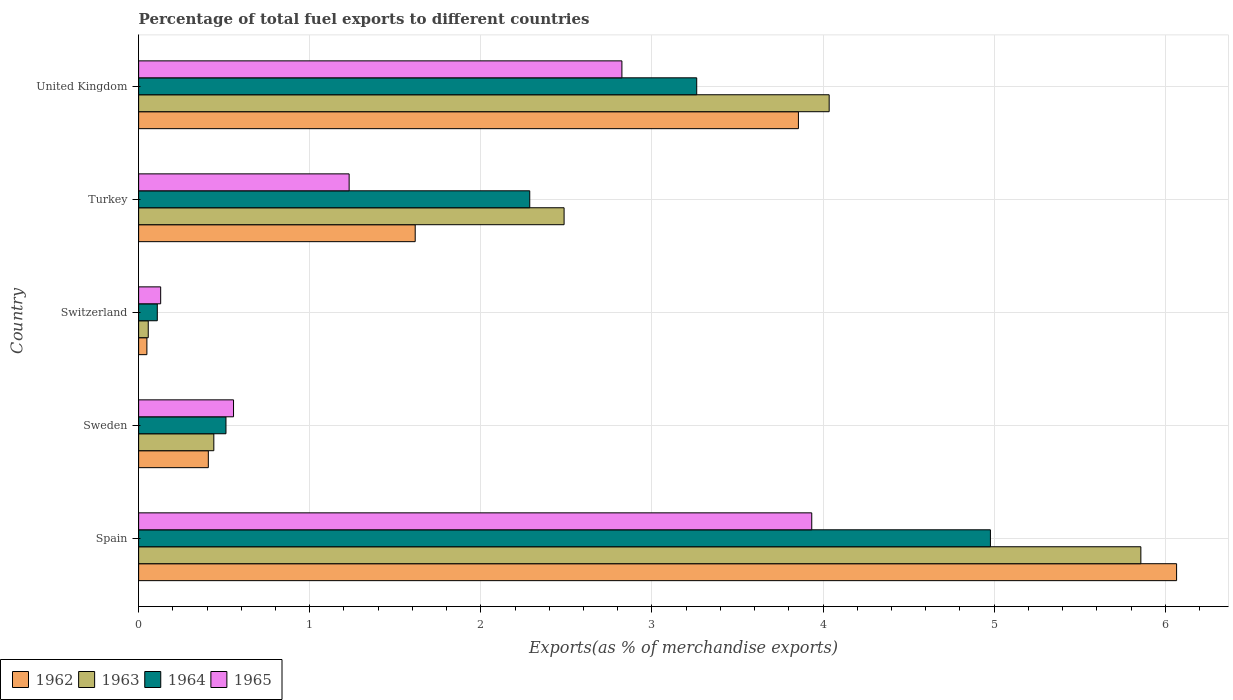Are the number of bars per tick equal to the number of legend labels?
Provide a succinct answer. Yes. How many bars are there on the 4th tick from the top?
Make the answer very short. 4. What is the label of the 4th group of bars from the top?
Your response must be concise. Sweden. In how many cases, is the number of bars for a given country not equal to the number of legend labels?
Provide a succinct answer. 0. What is the percentage of exports to different countries in 1963 in United Kingdom?
Make the answer very short. 4.04. Across all countries, what is the maximum percentage of exports to different countries in 1962?
Your answer should be very brief. 6.07. Across all countries, what is the minimum percentage of exports to different countries in 1963?
Your response must be concise. 0.06. In which country was the percentage of exports to different countries in 1962 maximum?
Make the answer very short. Spain. In which country was the percentage of exports to different countries in 1963 minimum?
Make the answer very short. Switzerland. What is the total percentage of exports to different countries in 1963 in the graph?
Give a very brief answer. 12.88. What is the difference between the percentage of exports to different countries in 1963 in Spain and that in Switzerland?
Give a very brief answer. 5.8. What is the difference between the percentage of exports to different countries in 1963 in Turkey and the percentage of exports to different countries in 1962 in United Kingdom?
Give a very brief answer. -1.37. What is the average percentage of exports to different countries in 1963 per country?
Your answer should be very brief. 2.58. What is the difference between the percentage of exports to different countries in 1965 and percentage of exports to different countries in 1962 in Switzerland?
Offer a terse response. 0.08. What is the ratio of the percentage of exports to different countries in 1965 in Spain to that in Sweden?
Give a very brief answer. 7.09. Is the percentage of exports to different countries in 1963 in Switzerland less than that in United Kingdom?
Ensure brevity in your answer.  Yes. Is the difference between the percentage of exports to different countries in 1965 in Switzerland and United Kingdom greater than the difference between the percentage of exports to different countries in 1962 in Switzerland and United Kingdom?
Your answer should be very brief. Yes. What is the difference between the highest and the second highest percentage of exports to different countries in 1965?
Give a very brief answer. 1.11. What is the difference between the highest and the lowest percentage of exports to different countries in 1962?
Provide a short and direct response. 6.02. What does the 2nd bar from the top in Spain represents?
Offer a terse response. 1964. Does the graph contain any zero values?
Ensure brevity in your answer.  No. Does the graph contain grids?
Your response must be concise. Yes. How many legend labels are there?
Give a very brief answer. 4. How are the legend labels stacked?
Your answer should be very brief. Horizontal. What is the title of the graph?
Keep it short and to the point. Percentage of total fuel exports to different countries. What is the label or title of the X-axis?
Ensure brevity in your answer.  Exports(as % of merchandise exports). What is the Exports(as % of merchandise exports) in 1962 in Spain?
Provide a short and direct response. 6.07. What is the Exports(as % of merchandise exports) of 1963 in Spain?
Make the answer very short. 5.86. What is the Exports(as % of merchandise exports) in 1964 in Spain?
Give a very brief answer. 4.98. What is the Exports(as % of merchandise exports) of 1965 in Spain?
Your response must be concise. 3.93. What is the Exports(as % of merchandise exports) in 1962 in Sweden?
Your answer should be compact. 0.41. What is the Exports(as % of merchandise exports) in 1963 in Sweden?
Offer a very short reply. 0.44. What is the Exports(as % of merchandise exports) of 1964 in Sweden?
Keep it short and to the point. 0.51. What is the Exports(as % of merchandise exports) in 1965 in Sweden?
Offer a very short reply. 0.55. What is the Exports(as % of merchandise exports) in 1962 in Switzerland?
Offer a very short reply. 0.05. What is the Exports(as % of merchandise exports) of 1963 in Switzerland?
Offer a terse response. 0.06. What is the Exports(as % of merchandise exports) in 1964 in Switzerland?
Ensure brevity in your answer.  0.11. What is the Exports(as % of merchandise exports) of 1965 in Switzerland?
Your answer should be compact. 0.13. What is the Exports(as % of merchandise exports) of 1962 in Turkey?
Offer a very short reply. 1.62. What is the Exports(as % of merchandise exports) of 1963 in Turkey?
Keep it short and to the point. 2.49. What is the Exports(as % of merchandise exports) in 1964 in Turkey?
Make the answer very short. 2.29. What is the Exports(as % of merchandise exports) in 1965 in Turkey?
Offer a very short reply. 1.23. What is the Exports(as % of merchandise exports) in 1962 in United Kingdom?
Your answer should be compact. 3.86. What is the Exports(as % of merchandise exports) of 1963 in United Kingdom?
Make the answer very short. 4.04. What is the Exports(as % of merchandise exports) of 1964 in United Kingdom?
Your response must be concise. 3.26. What is the Exports(as % of merchandise exports) of 1965 in United Kingdom?
Provide a succinct answer. 2.82. Across all countries, what is the maximum Exports(as % of merchandise exports) in 1962?
Give a very brief answer. 6.07. Across all countries, what is the maximum Exports(as % of merchandise exports) in 1963?
Keep it short and to the point. 5.86. Across all countries, what is the maximum Exports(as % of merchandise exports) of 1964?
Make the answer very short. 4.98. Across all countries, what is the maximum Exports(as % of merchandise exports) in 1965?
Offer a terse response. 3.93. Across all countries, what is the minimum Exports(as % of merchandise exports) in 1962?
Offer a terse response. 0.05. Across all countries, what is the minimum Exports(as % of merchandise exports) in 1963?
Offer a terse response. 0.06. Across all countries, what is the minimum Exports(as % of merchandise exports) in 1964?
Your response must be concise. 0.11. Across all countries, what is the minimum Exports(as % of merchandise exports) of 1965?
Offer a terse response. 0.13. What is the total Exports(as % of merchandise exports) of 1962 in the graph?
Make the answer very short. 11.99. What is the total Exports(as % of merchandise exports) of 1963 in the graph?
Your answer should be very brief. 12.88. What is the total Exports(as % of merchandise exports) in 1964 in the graph?
Offer a terse response. 11.14. What is the total Exports(as % of merchandise exports) of 1965 in the graph?
Offer a terse response. 8.67. What is the difference between the Exports(as % of merchandise exports) in 1962 in Spain and that in Sweden?
Keep it short and to the point. 5.66. What is the difference between the Exports(as % of merchandise exports) in 1963 in Spain and that in Sweden?
Provide a succinct answer. 5.42. What is the difference between the Exports(as % of merchandise exports) in 1964 in Spain and that in Sweden?
Your answer should be compact. 4.47. What is the difference between the Exports(as % of merchandise exports) in 1965 in Spain and that in Sweden?
Offer a very short reply. 3.38. What is the difference between the Exports(as % of merchandise exports) in 1962 in Spain and that in Switzerland?
Offer a very short reply. 6.02. What is the difference between the Exports(as % of merchandise exports) in 1963 in Spain and that in Switzerland?
Make the answer very short. 5.8. What is the difference between the Exports(as % of merchandise exports) of 1964 in Spain and that in Switzerland?
Make the answer very short. 4.87. What is the difference between the Exports(as % of merchandise exports) of 1965 in Spain and that in Switzerland?
Provide a short and direct response. 3.81. What is the difference between the Exports(as % of merchandise exports) of 1962 in Spain and that in Turkey?
Ensure brevity in your answer.  4.45. What is the difference between the Exports(as % of merchandise exports) in 1963 in Spain and that in Turkey?
Make the answer very short. 3.37. What is the difference between the Exports(as % of merchandise exports) in 1964 in Spain and that in Turkey?
Offer a terse response. 2.69. What is the difference between the Exports(as % of merchandise exports) of 1965 in Spain and that in Turkey?
Offer a terse response. 2.7. What is the difference between the Exports(as % of merchandise exports) of 1962 in Spain and that in United Kingdom?
Offer a terse response. 2.21. What is the difference between the Exports(as % of merchandise exports) of 1963 in Spain and that in United Kingdom?
Make the answer very short. 1.82. What is the difference between the Exports(as % of merchandise exports) in 1964 in Spain and that in United Kingdom?
Make the answer very short. 1.72. What is the difference between the Exports(as % of merchandise exports) in 1965 in Spain and that in United Kingdom?
Your answer should be compact. 1.11. What is the difference between the Exports(as % of merchandise exports) of 1962 in Sweden and that in Switzerland?
Your answer should be very brief. 0.36. What is the difference between the Exports(as % of merchandise exports) of 1963 in Sweden and that in Switzerland?
Give a very brief answer. 0.38. What is the difference between the Exports(as % of merchandise exports) of 1964 in Sweden and that in Switzerland?
Give a very brief answer. 0.4. What is the difference between the Exports(as % of merchandise exports) of 1965 in Sweden and that in Switzerland?
Your answer should be very brief. 0.43. What is the difference between the Exports(as % of merchandise exports) of 1962 in Sweden and that in Turkey?
Your answer should be compact. -1.21. What is the difference between the Exports(as % of merchandise exports) in 1963 in Sweden and that in Turkey?
Give a very brief answer. -2.05. What is the difference between the Exports(as % of merchandise exports) in 1964 in Sweden and that in Turkey?
Your response must be concise. -1.78. What is the difference between the Exports(as % of merchandise exports) of 1965 in Sweden and that in Turkey?
Offer a terse response. -0.68. What is the difference between the Exports(as % of merchandise exports) in 1962 in Sweden and that in United Kingdom?
Your response must be concise. -3.45. What is the difference between the Exports(as % of merchandise exports) of 1963 in Sweden and that in United Kingdom?
Ensure brevity in your answer.  -3.6. What is the difference between the Exports(as % of merchandise exports) of 1964 in Sweden and that in United Kingdom?
Offer a very short reply. -2.75. What is the difference between the Exports(as % of merchandise exports) in 1965 in Sweden and that in United Kingdom?
Your response must be concise. -2.27. What is the difference between the Exports(as % of merchandise exports) in 1962 in Switzerland and that in Turkey?
Your answer should be very brief. -1.57. What is the difference between the Exports(as % of merchandise exports) in 1963 in Switzerland and that in Turkey?
Offer a very short reply. -2.43. What is the difference between the Exports(as % of merchandise exports) of 1964 in Switzerland and that in Turkey?
Provide a short and direct response. -2.18. What is the difference between the Exports(as % of merchandise exports) of 1965 in Switzerland and that in Turkey?
Make the answer very short. -1.1. What is the difference between the Exports(as % of merchandise exports) in 1962 in Switzerland and that in United Kingdom?
Ensure brevity in your answer.  -3.81. What is the difference between the Exports(as % of merchandise exports) in 1963 in Switzerland and that in United Kingdom?
Your answer should be compact. -3.98. What is the difference between the Exports(as % of merchandise exports) of 1964 in Switzerland and that in United Kingdom?
Give a very brief answer. -3.15. What is the difference between the Exports(as % of merchandise exports) of 1965 in Switzerland and that in United Kingdom?
Your answer should be compact. -2.7. What is the difference between the Exports(as % of merchandise exports) of 1962 in Turkey and that in United Kingdom?
Provide a short and direct response. -2.24. What is the difference between the Exports(as % of merchandise exports) of 1963 in Turkey and that in United Kingdom?
Ensure brevity in your answer.  -1.55. What is the difference between the Exports(as % of merchandise exports) in 1964 in Turkey and that in United Kingdom?
Your answer should be compact. -0.98. What is the difference between the Exports(as % of merchandise exports) in 1965 in Turkey and that in United Kingdom?
Your response must be concise. -1.59. What is the difference between the Exports(as % of merchandise exports) of 1962 in Spain and the Exports(as % of merchandise exports) of 1963 in Sweden?
Ensure brevity in your answer.  5.63. What is the difference between the Exports(as % of merchandise exports) in 1962 in Spain and the Exports(as % of merchandise exports) in 1964 in Sweden?
Give a very brief answer. 5.56. What is the difference between the Exports(as % of merchandise exports) in 1962 in Spain and the Exports(as % of merchandise exports) in 1965 in Sweden?
Offer a very short reply. 5.51. What is the difference between the Exports(as % of merchandise exports) of 1963 in Spain and the Exports(as % of merchandise exports) of 1964 in Sweden?
Provide a succinct answer. 5.35. What is the difference between the Exports(as % of merchandise exports) of 1963 in Spain and the Exports(as % of merchandise exports) of 1965 in Sweden?
Provide a succinct answer. 5.3. What is the difference between the Exports(as % of merchandise exports) in 1964 in Spain and the Exports(as % of merchandise exports) in 1965 in Sweden?
Make the answer very short. 4.42. What is the difference between the Exports(as % of merchandise exports) of 1962 in Spain and the Exports(as % of merchandise exports) of 1963 in Switzerland?
Your response must be concise. 6.01. What is the difference between the Exports(as % of merchandise exports) in 1962 in Spain and the Exports(as % of merchandise exports) in 1964 in Switzerland?
Your answer should be very brief. 5.96. What is the difference between the Exports(as % of merchandise exports) in 1962 in Spain and the Exports(as % of merchandise exports) in 1965 in Switzerland?
Your response must be concise. 5.94. What is the difference between the Exports(as % of merchandise exports) in 1963 in Spain and the Exports(as % of merchandise exports) in 1964 in Switzerland?
Your response must be concise. 5.75. What is the difference between the Exports(as % of merchandise exports) of 1963 in Spain and the Exports(as % of merchandise exports) of 1965 in Switzerland?
Provide a short and direct response. 5.73. What is the difference between the Exports(as % of merchandise exports) of 1964 in Spain and the Exports(as % of merchandise exports) of 1965 in Switzerland?
Give a very brief answer. 4.85. What is the difference between the Exports(as % of merchandise exports) in 1962 in Spain and the Exports(as % of merchandise exports) in 1963 in Turkey?
Provide a short and direct response. 3.58. What is the difference between the Exports(as % of merchandise exports) in 1962 in Spain and the Exports(as % of merchandise exports) in 1964 in Turkey?
Your answer should be very brief. 3.78. What is the difference between the Exports(as % of merchandise exports) in 1962 in Spain and the Exports(as % of merchandise exports) in 1965 in Turkey?
Your answer should be compact. 4.84. What is the difference between the Exports(as % of merchandise exports) in 1963 in Spain and the Exports(as % of merchandise exports) in 1964 in Turkey?
Provide a short and direct response. 3.57. What is the difference between the Exports(as % of merchandise exports) of 1963 in Spain and the Exports(as % of merchandise exports) of 1965 in Turkey?
Ensure brevity in your answer.  4.63. What is the difference between the Exports(as % of merchandise exports) in 1964 in Spain and the Exports(as % of merchandise exports) in 1965 in Turkey?
Provide a succinct answer. 3.75. What is the difference between the Exports(as % of merchandise exports) of 1962 in Spain and the Exports(as % of merchandise exports) of 1963 in United Kingdom?
Keep it short and to the point. 2.03. What is the difference between the Exports(as % of merchandise exports) in 1962 in Spain and the Exports(as % of merchandise exports) in 1964 in United Kingdom?
Provide a short and direct response. 2.8. What is the difference between the Exports(as % of merchandise exports) in 1962 in Spain and the Exports(as % of merchandise exports) in 1965 in United Kingdom?
Your answer should be compact. 3.24. What is the difference between the Exports(as % of merchandise exports) in 1963 in Spain and the Exports(as % of merchandise exports) in 1964 in United Kingdom?
Your response must be concise. 2.6. What is the difference between the Exports(as % of merchandise exports) of 1963 in Spain and the Exports(as % of merchandise exports) of 1965 in United Kingdom?
Your answer should be very brief. 3.03. What is the difference between the Exports(as % of merchandise exports) of 1964 in Spain and the Exports(as % of merchandise exports) of 1965 in United Kingdom?
Your answer should be compact. 2.15. What is the difference between the Exports(as % of merchandise exports) of 1962 in Sweden and the Exports(as % of merchandise exports) of 1963 in Switzerland?
Provide a short and direct response. 0.35. What is the difference between the Exports(as % of merchandise exports) of 1962 in Sweden and the Exports(as % of merchandise exports) of 1964 in Switzerland?
Your response must be concise. 0.3. What is the difference between the Exports(as % of merchandise exports) in 1962 in Sweden and the Exports(as % of merchandise exports) in 1965 in Switzerland?
Give a very brief answer. 0.28. What is the difference between the Exports(as % of merchandise exports) in 1963 in Sweden and the Exports(as % of merchandise exports) in 1964 in Switzerland?
Ensure brevity in your answer.  0.33. What is the difference between the Exports(as % of merchandise exports) of 1963 in Sweden and the Exports(as % of merchandise exports) of 1965 in Switzerland?
Keep it short and to the point. 0.31. What is the difference between the Exports(as % of merchandise exports) of 1964 in Sweden and the Exports(as % of merchandise exports) of 1965 in Switzerland?
Your response must be concise. 0.38. What is the difference between the Exports(as % of merchandise exports) in 1962 in Sweden and the Exports(as % of merchandise exports) in 1963 in Turkey?
Provide a succinct answer. -2.08. What is the difference between the Exports(as % of merchandise exports) in 1962 in Sweden and the Exports(as % of merchandise exports) in 1964 in Turkey?
Keep it short and to the point. -1.88. What is the difference between the Exports(as % of merchandise exports) in 1962 in Sweden and the Exports(as % of merchandise exports) in 1965 in Turkey?
Ensure brevity in your answer.  -0.82. What is the difference between the Exports(as % of merchandise exports) of 1963 in Sweden and the Exports(as % of merchandise exports) of 1964 in Turkey?
Offer a very short reply. -1.85. What is the difference between the Exports(as % of merchandise exports) of 1963 in Sweden and the Exports(as % of merchandise exports) of 1965 in Turkey?
Your response must be concise. -0.79. What is the difference between the Exports(as % of merchandise exports) of 1964 in Sweden and the Exports(as % of merchandise exports) of 1965 in Turkey?
Provide a succinct answer. -0.72. What is the difference between the Exports(as % of merchandise exports) of 1962 in Sweden and the Exports(as % of merchandise exports) of 1963 in United Kingdom?
Keep it short and to the point. -3.63. What is the difference between the Exports(as % of merchandise exports) in 1962 in Sweden and the Exports(as % of merchandise exports) in 1964 in United Kingdom?
Your answer should be compact. -2.85. What is the difference between the Exports(as % of merchandise exports) of 1962 in Sweden and the Exports(as % of merchandise exports) of 1965 in United Kingdom?
Your answer should be compact. -2.42. What is the difference between the Exports(as % of merchandise exports) in 1963 in Sweden and the Exports(as % of merchandise exports) in 1964 in United Kingdom?
Give a very brief answer. -2.82. What is the difference between the Exports(as % of merchandise exports) in 1963 in Sweden and the Exports(as % of merchandise exports) in 1965 in United Kingdom?
Make the answer very short. -2.38. What is the difference between the Exports(as % of merchandise exports) in 1964 in Sweden and the Exports(as % of merchandise exports) in 1965 in United Kingdom?
Give a very brief answer. -2.31. What is the difference between the Exports(as % of merchandise exports) of 1962 in Switzerland and the Exports(as % of merchandise exports) of 1963 in Turkey?
Make the answer very short. -2.44. What is the difference between the Exports(as % of merchandise exports) of 1962 in Switzerland and the Exports(as % of merchandise exports) of 1964 in Turkey?
Provide a short and direct response. -2.24. What is the difference between the Exports(as % of merchandise exports) in 1962 in Switzerland and the Exports(as % of merchandise exports) in 1965 in Turkey?
Your response must be concise. -1.18. What is the difference between the Exports(as % of merchandise exports) of 1963 in Switzerland and the Exports(as % of merchandise exports) of 1964 in Turkey?
Your answer should be compact. -2.23. What is the difference between the Exports(as % of merchandise exports) in 1963 in Switzerland and the Exports(as % of merchandise exports) in 1965 in Turkey?
Your answer should be compact. -1.17. What is the difference between the Exports(as % of merchandise exports) of 1964 in Switzerland and the Exports(as % of merchandise exports) of 1965 in Turkey?
Provide a succinct answer. -1.12. What is the difference between the Exports(as % of merchandise exports) of 1962 in Switzerland and the Exports(as % of merchandise exports) of 1963 in United Kingdom?
Offer a very short reply. -3.99. What is the difference between the Exports(as % of merchandise exports) in 1962 in Switzerland and the Exports(as % of merchandise exports) in 1964 in United Kingdom?
Provide a short and direct response. -3.21. What is the difference between the Exports(as % of merchandise exports) of 1962 in Switzerland and the Exports(as % of merchandise exports) of 1965 in United Kingdom?
Make the answer very short. -2.78. What is the difference between the Exports(as % of merchandise exports) of 1963 in Switzerland and the Exports(as % of merchandise exports) of 1964 in United Kingdom?
Keep it short and to the point. -3.21. What is the difference between the Exports(as % of merchandise exports) in 1963 in Switzerland and the Exports(as % of merchandise exports) in 1965 in United Kingdom?
Provide a short and direct response. -2.77. What is the difference between the Exports(as % of merchandise exports) in 1964 in Switzerland and the Exports(as % of merchandise exports) in 1965 in United Kingdom?
Offer a terse response. -2.72. What is the difference between the Exports(as % of merchandise exports) of 1962 in Turkey and the Exports(as % of merchandise exports) of 1963 in United Kingdom?
Offer a terse response. -2.42. What is the difference between the Exports(as % of merchandise exports) of 1962 in Turkey and the Exports(as % of merchandise exports) of 1964 in United Kingdom?
Your response must be concise. -1.65. What is the difference between the Exports(as % of merchandise exports) in 1962 in Turkey and the Exports(as % of merchandise exports) in 1965 in United Kingdom?
Your answer should be compact. -1.21. What is the difference between the Exports(as % of merchandise exports) in 1963 in Turkey and the Exports(as % of merchandise exports) in 1964 in United Kingdom?
Provide a short and direct response. -0.78. What is the difference between the Exports(as % of merchandise exports) of 1963 in Turkey and the Exports(as % of merchandise exports) of 1965 in United Kingdom?
Offer a very short reply. -0.34. What is the difference between the Exports(as % of merchandise exports) of 1964 in Turkey and the Exports(as % of merchandise exports) of 1965 in United Kingdom?
Your answer should be compact. -0.54. What is the average Exports(as % of merchandise exports) in 1962 per country?
Offer a terse response. 2.4. What is the average Exports(as % of merchandise exports) of 1963 per country?
Keep it short and to the point. 2.58. What is the average Exports(as % of merchandise exports) of 1964 per country?
Your response must be concise. 2.23. What is the average Exports(as % of merchandise exports) of 1965 per country?
Your response must be concise. 1.73. What is the difference between the Exports(as % of merchandise exports) of 1962 and Exports(as % of merchandise exports) of 1963 in Spain?
Provide a succinct answer. 0.21. What is the difference between the Exports(as % of merchandise exports) of 1962 and Exports(as % of merchandise exports) of 1964 in Spain?
Your response must be concise. 1.09. What is the difference between the Exports(as % of merchandise exports) of 1962 and Exports(as % of merchandise exports) of 1965 in Spain?
Make the answer very short. 2.13. What is the difference between the Exports(as % of merchandise exports) of 1963 and Exports(as % of merchandise exports) of 1964 in Spain?
Offer a terse response. 0.88. What is the difference between the Exports(as % of merchandise exports) in 1963 and Exports(as % of merchandise exports) in 1965 in Spain?
Give a very brief answer. 1.92. What is the difference between the Exports(as % of merchandise exports) of 1964 and Exports(as % of merchandise exports) of 1965 in Spain?
Make the answer very short. 1.04. What is the difference between the Exports(as % of merchandise exports) in 1962 and Exports(as % of merchandise exports) in 1963 in Sweden?
Ensure brevity in your answer.  -0.03. What is the difference between the Exports(as % of merchandise exports) of 1962 and Exports(as % of merchandise exports) of 1964 in Sweden?
Keep it short and to the point. -0.1. What is the difference between the Exports(as % of merchandise exports) in 1962 and Exports(as % of merchandise exports) in 1965 in Sweden?
Ensure brevity in your answer.  -0.15. What is the difference between the Exports(as % of merchandise exports) of 1963 and Exports(as % of merchandise exports) of 1964 in Sweden?
Your answer should be very brief. -0.07. What is the difference between the Exports(as % of merchandise exports) of 1963 and Exports(as % of merchandise exports) of 1965 in Sweden?
Provide a short and direct response. -0.12. What is the difference between the Exports(as % of merchandise exports) in 1964 and Exports(as % of merchandise exports) in 1965 in Sweden?
Make the answer very short. -0.04. What is the difference between the Exports(as % of merchandise exports) in 1962 and Exports(as % of merchandise exports) in 1963 in Switzerland?
Your response must be concise. -0.01. What is the difference between the Exports(as % of merchandise exports) of 1962 and Exports(as % of merchandise exports) of 1964 in Switzerland?
Your response must be concise. -0.06. What is the difference between the Exports(as % of merchandise exports) in 1962 and Exports(as % of merchandise exports) in 1965 in Switzerland?
Your response must be concise. -0.08. What is the difference between the Exports(as % of merchandise exports) of 1963 and Exports(as % of merchandise exports) of 1964 in Switzerland?
Offer a terse response. -0.05. What is the difference between the Exports(as % of merchandise exports) of 1963 and Exports(as % of merchandise exports) of 1965 in Switzerland?
Offer a very short reply. -0.07. What is the difference between the Exports(as % of merchandise exports) in 1964 and Exports(as % of merchandise exports) in 1965 in Switzerland?
Your answer should be compact. -0.02. What is the difference between the Exports(as % of merchandise exports) of 1962 and Exports(as % of merchandise exports) of 1963 in Turkey?
Give a very brief answer. -0.87. What is the difference between the Exports(as % of merchandise exports) of 1962 and Exports(as % of merchandise exports) of 1964 in Turkey?
Offer a very short reply. -0.67. What is the difference between the Exports(as % of merchandise exports) in 1962 and Exports(as % of merchandise exports) in 1965 in Turkey?
Ensure brevity in your answer.  0.39. What is the difference between the Exports(as % of merchandise exports) of 1963 and Exports(as % of merchandise exports) of 1964 in Turkey?
Your answer should be very brief. 0.2. What is the difference between the Exports(as % of merchandise exports) of 1963 and Exports(as % of merchandise exports) of 1965 in Turkey?
Keep it short and to the point. 1.26. What is the difference between the Exports(as % of merchandise exports) of 1964 and Exports(as % of merchandise exports) of 1965 in Turkey?
Provide a short and direct response. 1.06. What is the difference between the Exports(as % of merchandise exports) in 1962 and Exports(as % of merchandise exports) in 1963 in United Kingdom?
Your answer should be very brief. -0.18. What is the difference between the Exports(as % of merchandise exports) in 1962 and Exports(as % of merchandise exports) in 1964 in United Kingdom?
Make the answer very short. 0.59. What is the difference between the Exports(as % of merchandise exports) in 1962 and Exports(as % of merchandise exports) in 1965 in United Kingdom?
Keep it short and to the point. 1.03. What is the difference between the Exports(as % of merchandise exports) in 1963 and Exports(as % of merchandise exports) in 1964 in United Kingdom?
Make the answer very short. 0.77. What is the difference between the Exports(as % of merchandise exports) of 1963 and Exports(as % of merchandise exports) of 1965 in United Kingdom?
Your answer should be compact. 1.21. What is the difference between the Exports(as % of merchandise exports) of 1964 and Exports(as % of merchandise exports) of 1965 in United Kingdom?
Ensure brevity in your answer.  0.44. What is the ratio of the Exports(as % of merchandise exports) of 1962 in Spain to that in Sweden?
Keep it short and to the point. 14.89. What is the ratio of the Exports(as % of merchandise exports) of 1963 in Spain to that in Sweden?
Your answer should be very brief. 13.33. What is the ratio of the Exports(as % of merchandise exports) of 1964 in Spain to that in Sweden?
Offer a terse response. 9.75. What is the ratio of the Exports(as % of merchandise exports) in 1965 in Spain to that in Sweden?
Provide a succinct answer. 7.09. What is the ratio of the Exports(as % of merchandise exports) in 1962 in Spain to that in Switzerland?
Ensure brevity in your answer.  125.74. What is the ratio of the Exports(as % of merchandise exports) in 1963 in Spain to that in Switzerland?
Offer a terse response. 104.12. What is the ratio of the Exports(as % of merchandise exports) in 1964 in Spain to that in Switzerland?
Make the answer very short. 45.62. What is the ratio of the Exports(as % of merchandise exports) in 1965 in Spain to that in Switzerland?
Your response must be concise. 30.54. What is the ratio of the Exports(as % of merchandise exports) of 1962 in Spain to that in Turkey?
Offer a terse response. 3.75. What is the ratio of the Exports(as % of merchandise exports) in 1963 in Spain to that in Turkey?
Provide a short and direct response. 2.36. What is the ratio of the Exports(as % of merchandise exports) in 1964 in Spain to that in Turkey?
Ensure brevity in your answer.  2.18. What is the ratio of the Exports(as % of merchandise exports) in 1965 in Spain to that in Turkey?
Your response must be concise. 3.2. What is the ratio of the Exports(as % of merchandise exports) of 1962 in Spain to that in United Kingdom?
Provide a short and direct response. 1.57. What is the ratio of the Exports(as % of merchandise exports) in 1963 in Spain to that in United Kingdom?
Provide a short and direct response. 1.45. What is the ratio of the Exports(as % of merchandise exports) in 1964 in Spain to that in United Kingdom?
Make the answer very short. 1.53. What is the ratio of the Exports(as % of merchandise exports) in 1965 in Spain to that in United Kingdom?
Keep it short and to the point. 1.39. What is the ratio of the Exports(as % of merchandise exports) in 1962 in Sweden to that in Switzerland?
Provide a succinct answer. 8.44. What is the ratio of the Exports(as % of merchandise exports) of 1963 in Sweden to that in Switzerland?
Offer a very short reply. 7.81. What is the ratio of the Exports(as % of merchandise exports) in 1964 in Sweden to that in Switzerland?
Your answer should be compact. 4.68. What is the ratio of the Exports(as % of merchandise exports) in 1965 in Sweden to that in Switzerland?
Provide a succinct answer. 4.31. What is the ratio of the Exports(as % of merchandise exports) of 1962 in Sweden to that in Turkey?
Your response must be concise. 0.25. What is the ratio of the Exports(as % of merchandise exports) in 1963 in Sweden to that in Turkey?
Your answer should be very brief. 0.18. What is the ratio of the Exports(as % of merchandise exports) of 1964 in Sweden to that in Turkey?
Keep it short and to the point. 0.22. What is the ratio of the Exports(as % of merchandise exports) in 1965 in Sweden to that in Turkey?
Your response must be concise. 0.45. What is the ratio of the Exports(as % of merchandise exports) in 1962 in Sweden to that in United Kingdom?
Keep it short and to the point. 0.11. What is the ratio of the Exports(as % of merchandise exports) in 1963 in Sweden to that in United Kingdom?
Offer a very short reply. 0.11. What is the ratio of the Exports(as % of merchandise exports) in 1964 in Sweden to that in United Kingdom?
Your response must be concise. 0.16. What is the ratio of the Exports(as % of merchandise exports) in 1965 in Sweden to that in United Kingdom?
Your answer should be very brief. 0.2. What is the ratio of the Exports(as % of merchandise exports) in 1962 in Switzerland to that in Turkey?
Provide a short and direct response. 0.03. What is the ratio of the Exports(as % of merchandise exports) of 1963 in Switzerland to that in Turkey?
Provide a short and direct response. 0.02. What is the ratio of the Exports(as % of merchandise exports) of 1964 in Switzerland to that in Turkey?
Your response must be concise. 0.05. What is the ratio of the Exports(as % of merchandise exports) of 1965 in Switzerland to that in Turkey?
Make the answer very short. 0.1. What is the ratio of the Exports(as % of merchandise exports) of 1962 in Switzerland to that in United Kingdom?
Ensure brevity in your answer.  0.01. What is the ratio of the Exports(as % of merchandise exports) in 1963 in Switzerland to that in United Kingdom?
Provide a short and direct response. 0.01. What is the ratio of the Exports(as % of merchandise exports) of 1964 in Switzerland to that in United Kingdom?
Ensure brevity in your answer.  0.03. What is the ratio of the Exports(as % of merchandise exports) in 1965 in Switzerland to that in United Kingdom?
Your answer should be very brief. 0.05. What is the ratio of the Exports(as % of merchandise exports) in 1962 in Turkey to that in United Kingdom?
Make the answer very short. 0.42. What is the ratio of the Exports(as % of merchandise exports) in 1963 in Turkey to that in United Kingdom?
Keep it short and to the point. 0.62. What is the ratio of the Exports(as % of merchandise exports) in 1964 in Turkey to that in United Kingdom?
Your answer should be compact. 0.7. What is the ratio of the Exports(as % of merchandise exports) in 1965 in Turkey to that in United Kingdom?
Your answer should be very brief. 0.44. What is the difference between the highest and the second highest Exports(as % of merchandise exports) of 1962?
Give a very brief answer. 2.21. What is the difference between the highest and the second highest Exports(as % of merchandise exports) of 1963?
Give a very brief answer. 1.82. What is the difference between the highest and the second highest Exports(as % of merchandise exports) in 1964?
Your answer should be compact. 1.72. What is the difference between the highest and the second highest Exports(as % of merchandise exports) of 1965?
Give a very brief answer. 1.11. What is the difference between the highest and the lowest Exports(as % of merchandise exports) in 1962?
Provide a short and direct response. 6.02. What is the difference between the highest and the lowest Exports(as % of merchandise exports) of 1963?
Offer a terse response. 5.8. What is the difference between the highest and the lowest Exports(as % of merchandise exports) in 1964?
Provide a short and direct response. 4.87. What is the difference between the highest and the lowest Exports(as % of merchandise exports) in 1965?
Give a very brief answer. 3.81. 